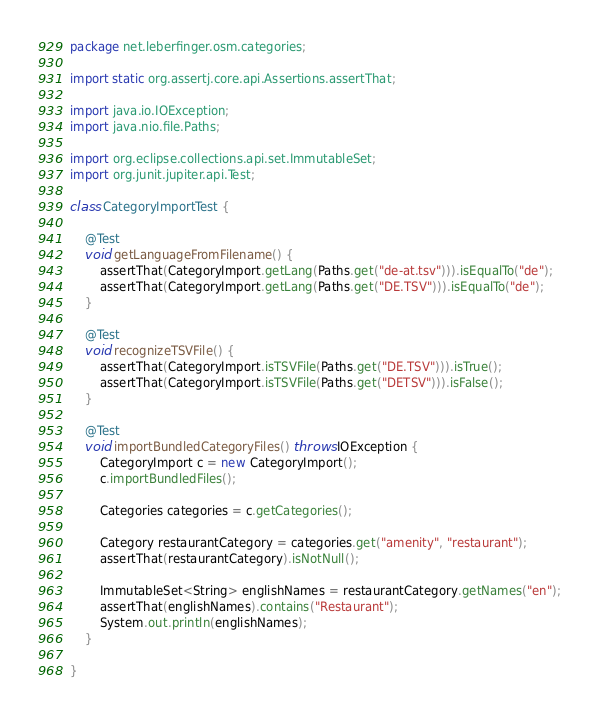Convert code to text. <code><loc_0><loc_0><loc_500><loc_500><_Java_>package net.leberfinger.osm.categories;

import static org.assertj.core.api.Assertions.assertThat;

import java.io.IOException;
import java.nio.file.Paths;

import org.eclipse.collections.api.set.ImmutableSet;
import org.junit.jupiter.api.Test;

class CategoryImportTest {

	@Test
	void getLanguageFromFilename() {
		assertThat(CategoryImport.getLang(Paths.get("de-at.tsv"))).isEqualTo("de");
		assertThat(CategoryImport.getLang(Paths.get("DE.TSV"))).isEqualTo("de");
	}

	@Test
	void recognizeTSVFile() {
		assertThat(CategoryImport.isTSVFile(Paths.get("DE.TSV"))).isTrue();
		assertThat(CategoryImport.isTSVFile(Paths.get("DETSV"))).isFalse();
	}

	@Test
	void importBundledCategoryFiles() throws IOException {
		CategoryImport c = new CategoryImport();
		c.importBundledFiles();

		Categories categories = c.getCategories();

		Category restaurantCategory = categories.get("amenity", "restaurant");
		assertThat(restaurantCategory).isNotNull();

		ImmutableSet<String> englishNames = restaurantCategory.getNames("en");
		assertThat(englishNames).contains("Restaurant");
		System.out.println(englishNames);
	}

}
</code> 